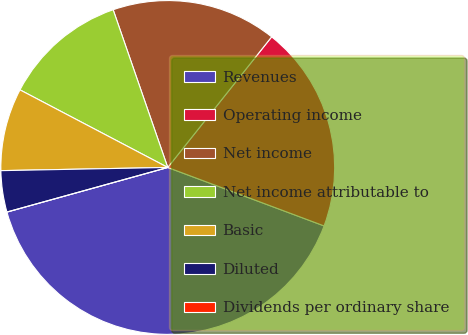Convert chart to OTSL. <chart><loc_0><loc_0><loc_500><loc_500><pie_chart><fcel>Revenues<fcel>Operating income<fcel>Net income<fcel>Net income attributable to<fcel>Basic<fcel>Diluted<fcel>Dividends per ordinary share<nl><fcel>40.0%<fcel>20.0%<fcel>16.0%<fcel>12.0%<fcel>8.0%<fcel>4.0%<fcel>0.0%<nl></chart> 